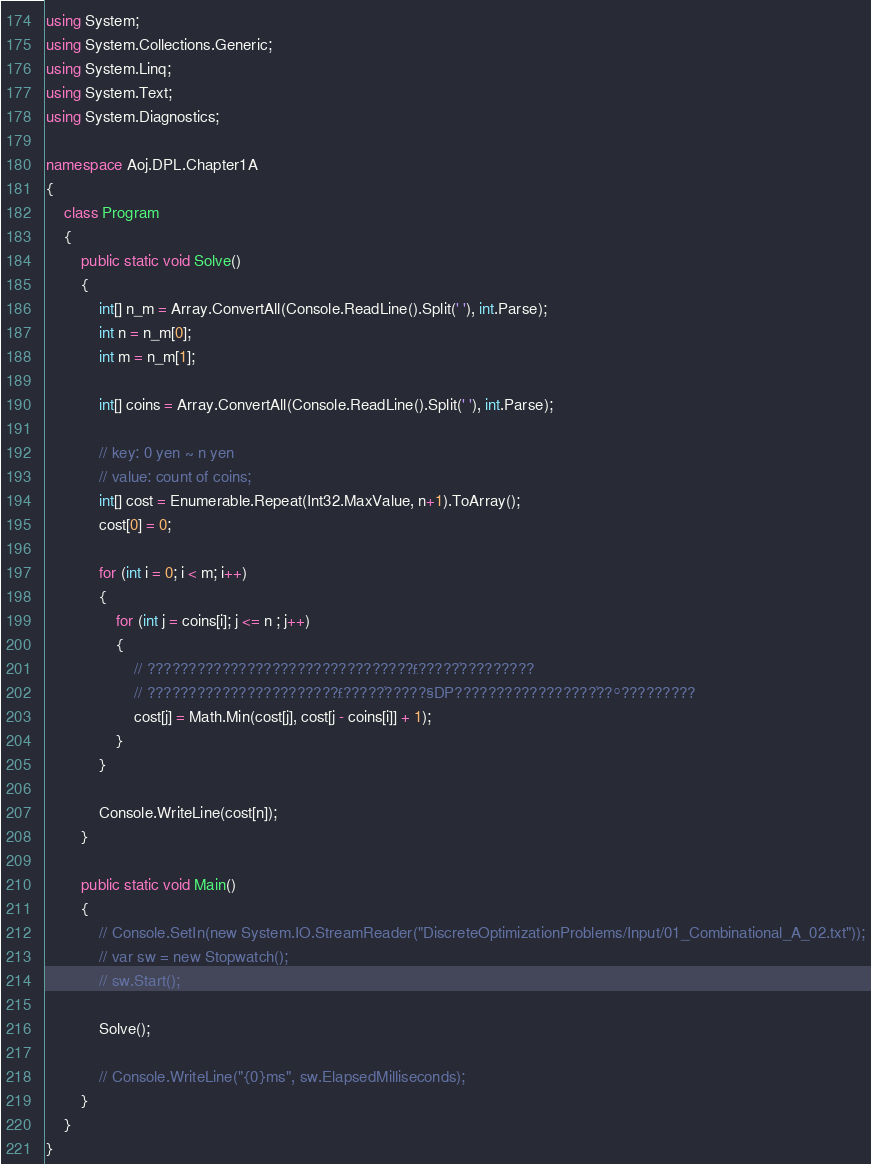Convert code to text. <code><loc_0><loc_0><loc_500><loc_500><_C#_>using System;
using System.Collections.Generic;
using System.Linq;
using System.Text;
using System.Diagnostics;

namespace Aoj.DPL.Chapter1A
{
    class Program
    {
        public static void Solve()
        {
            int[] n_m = Array.ConvertAll(Console.ReadLine().Split(' '), int.Parse);
            int n = n_m[0];
            int m = n_m[1];

            int[] coins = Array.ConvertAll(Console.ReadLine().Split(' '), int.Parse);

            // key: 0 yen ~ n yen
            // value: count of coins;
            int[] cost = Enumerable.Repeat(Int32.MaxValue, n+1).ToArray();
            cost[0] = 0;

            for (int i = 0; i < m; i++)
            {
                for (int j = coins[i]; j <= n ; j++)
                {
                    // ????????????????????????????????£?????´?????????
                    // ???????????????????????£?????´?????§DP?????????????????´??°?????????
                    cost[j] = Math.Min(cost[j], cost[j - coins[i]] + 1);
                }
            }

            Console.WriteLine(cost[n]);
        }

        public static void Main()
        {
            // Console.SetIn(new System.IO.StreamReader("DiscreteOptimizationProblems/Input/01_Combinational_A_02.txt"));
            // var sw = new Stopwatch();
            // sw.Start();

            Solve();

            // Console.WriteLine("{0}ms", sw.ElapsedMilliseconds);
        }
    }
}</code> 